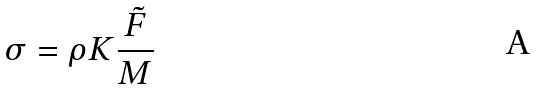Convert formula to latex. <formula><loc_0><loc_0><loc_500><loc_500>\sigma = \rho K \frac { \tilde { F } } { M }</formula> 